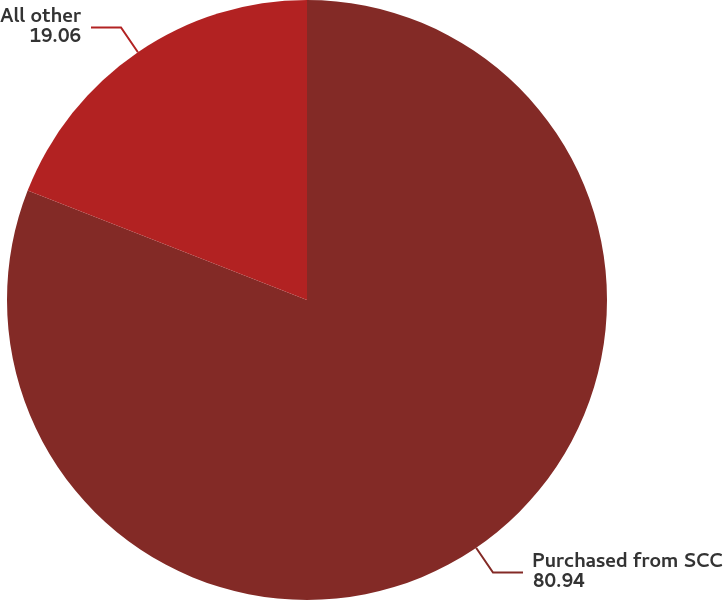<chart> <loc_0><loc_0><loc_500><loc_500><pie_chart><fcel>Purchased from SCC<fcel>All other<nl><fcel>80.94%<fcel>19.06%<nl></chart> 